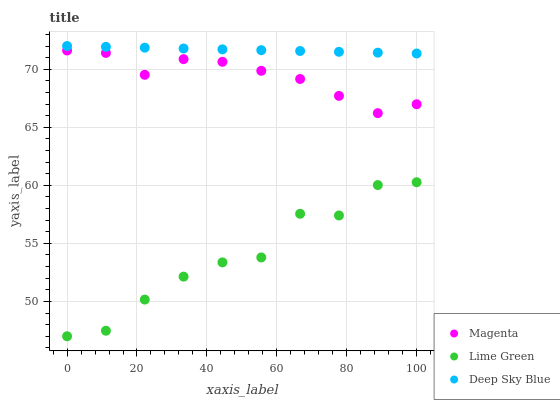Does Lime Green have the minimum area under the curve?
Answer yes or no. Yes. Does Deep Sky Blue have the maximum area under the curve?
Answer yes or no. Yes. Does Deep Sky Blue have the minimum area under the curve?
Answer yes or no. No. Does Lime Green have the maximum area under the curve?
Answer yes or no. No. Is Deep Sky Blue the smoothest?
Answer yes or no. Yes. Is Lime Green the roughest?
Answer yes or no. Yes. Is Lime Green the smoothest?
Answer yes or no. No. Is Deep Sky Blue the roughest?
Answer yes or no. No. Does Lime Green have the lowest value?
Answer yes or no. Yes. Does Deep Sky Blue have the lowest value?
Answer yes or no. No. Does Deep Sky Blue have the highest value?
Answer yes or no. Yes. Does Lime Green have the highest value?
Answer yes or no. No. Is Lime Green less than Deep Sky Blue?
Answer yes or no. Yes. Is Deep Sky Blue greater than Lime Green?
Answer yes or no. Yes. Does Lime Green intersect Deep Sky Blue?
Answer yes or no. No. 